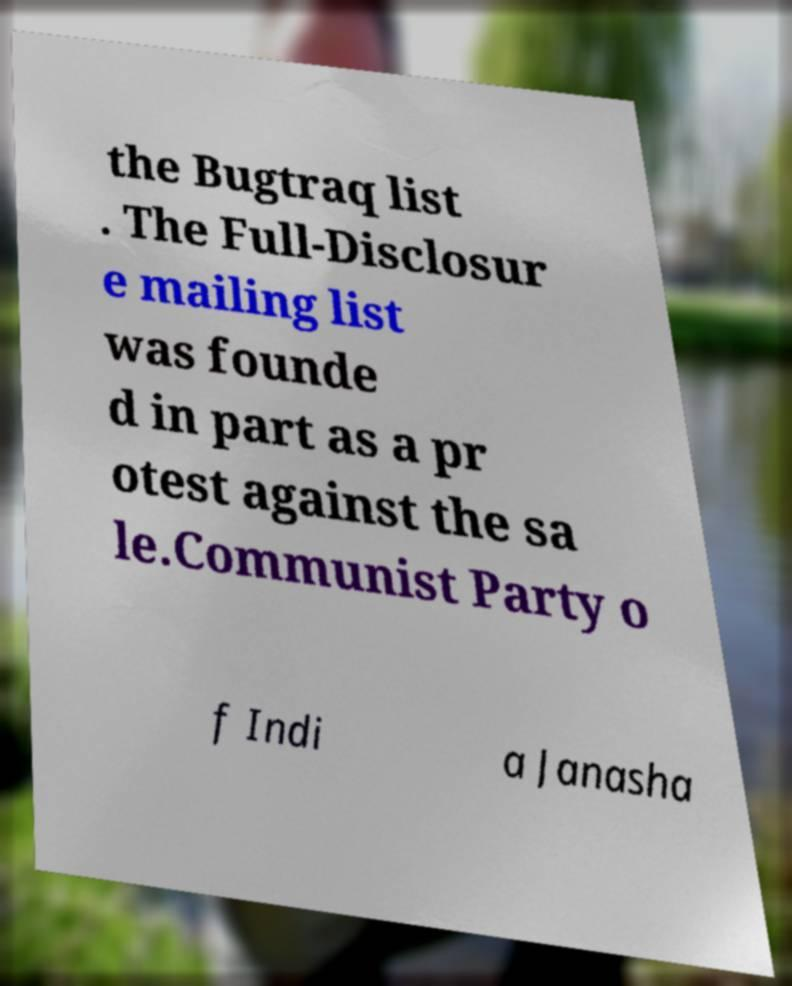Please identify and transcribe the text found in this image. the Bugtraq list . The Full-Disclosur e mailing list was founde d in part as a pr otest against the sa le.Communist Party o f Indi a Janasha 